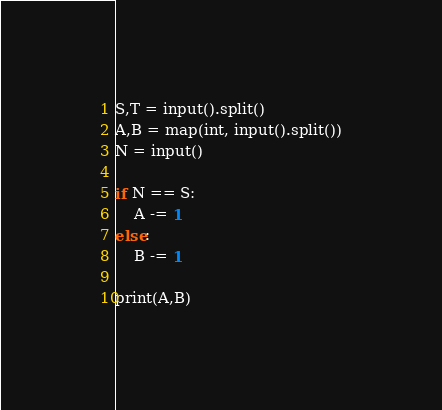Convert code to text. <code><loc_0><loc_0><loc_500><loc_500><_Python_>S,T = input().split()
A,B = map(int, input().split())
N = input()

if N == S:
    A -= 1
else:
    B -= 1

print(A,B)
</code> 